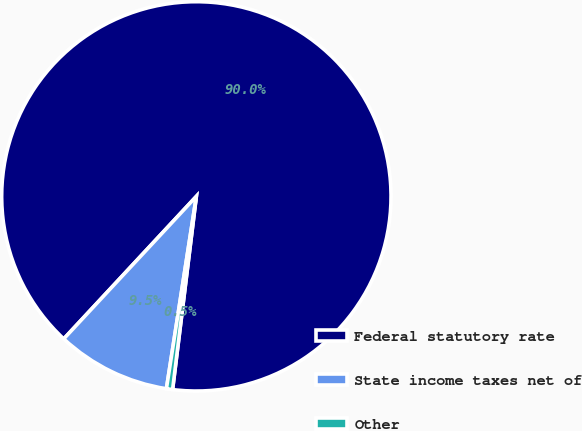Convert chart. <chart><loc_0><loc_0><loc_500><loc_500><pie_chart><fcel>Federal statutory rate<fcel>State income taxes net of<fcel>Other<nl><fcel>90.02%<fcel>9.47%<fcel>0.51%<nl></chart> 